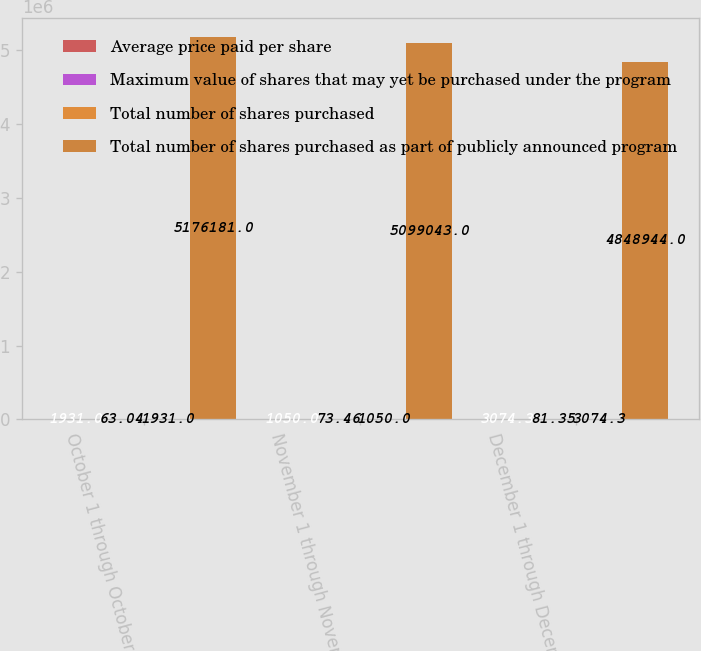Convert chart to OTSL. <chart><loc_0><loc_0><loc_500><loc_500><stacked_bar_chart><ecel><fcel>October 1 through October 31<fcel>November 1 through November 30<fcel>December 1 through December 31<nl><fcel>Average price paid per share<fcel>1931<fcel>1050<fcel>3074.3<nl><fcel>Maximum value of shares that may yet be purchased under the program<fcel>63.04<fcel>73.46<fcel>81.35<nl><fcel>Total number of shares purchased<fcel>1931<fcel>1050<fcel>3074.3<nl><fcel>Total number of shares purchased as part of publicly announced program<fcel>5.17618e+06<fcel>5.09904e+06<fcel>4.84894e+06<nl></chart> 